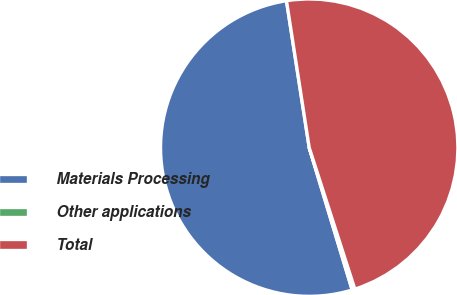<chart> <loc_0><loc_0><loc_500><loc_500><pie_chart><fcel>Materials Processing<fcel>Other applications<fcel>Total<nl><fcel>52.22%<fcel>0.3%<fcel>47.48%<nl></chart> 